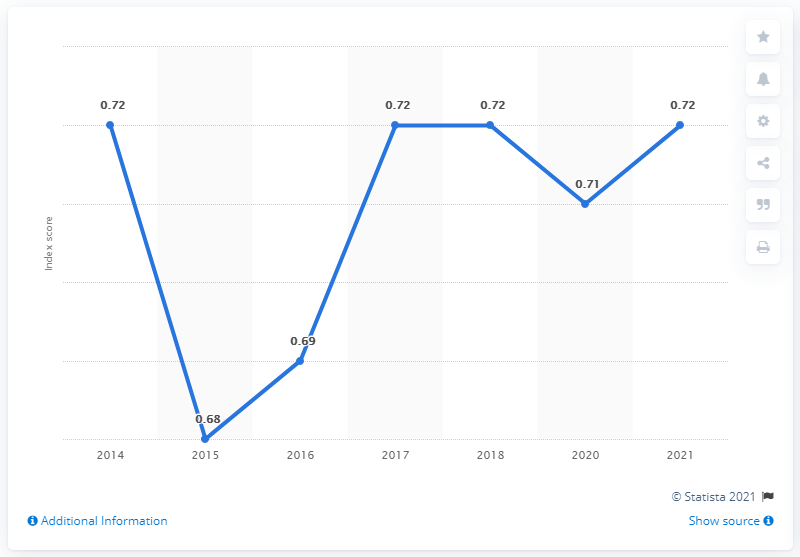Highlight a few significant elements in this photo. Peru's gender gap index score in 2021 was 0.72, indicating that the country has made progress in closing the gender gap, but there is still room for improvement. 